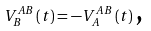<formula> <loc_0><loc_0><loc_500><loc_500>V ^ { A B } _ { B } \left ( t \right ) = - V ^ { A B } _ { A } \left ( t \right ) \text {,}</formula> 